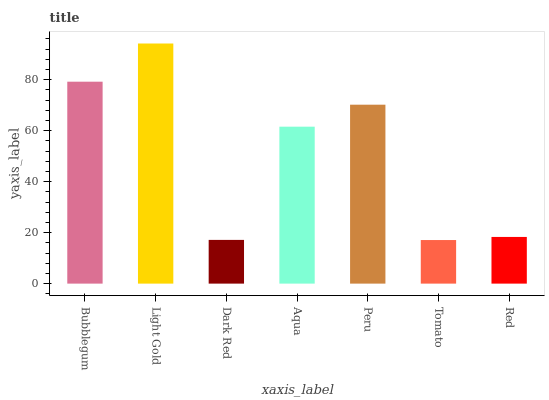Is Tomato the minimum?
Answer yes or no. Yes. Is Light Gold the maximum?
Answer yes or no. Yes. Is Dark Red the minimum?
Answer yes or no. No. Is Dark Red the maximum?
Answer yes or no. No. Is Light Gold greater than Dark Red?
Answer yes or no. Yes. Is Dark Red less than Light Gold?
Answer yes or no. Yes. Is Dark Red greater than Light Gold?
Answer yes or no. No. Is Light Gold less than Dark Red?
Answer yes or no. No. Is Aqua the high median?
Answer yes or no. Yes. Is Aqua the low median?
Answer yes or no. Yes. Is Peru the high median?
Answer yes or no. No. Is Peru the low median?
Answer yes or no. No. 